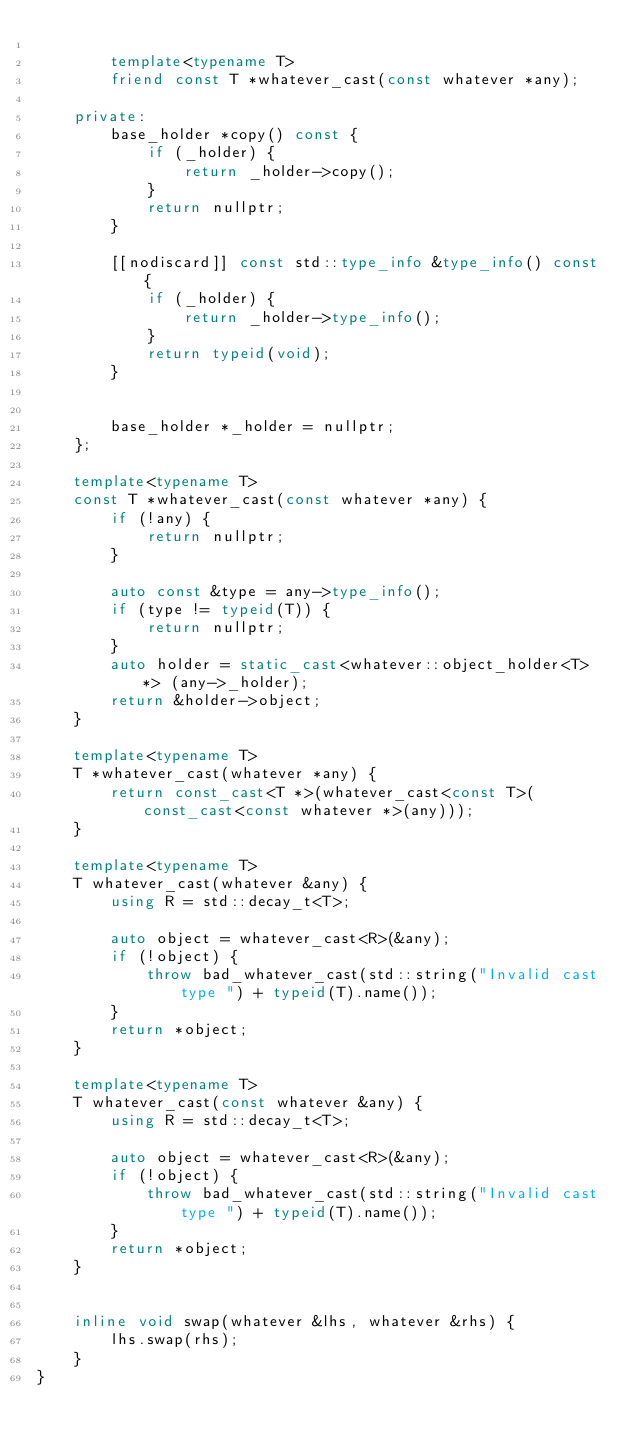Convert code to text. <code><loc_0><loc_0><loc_500><loc_500><_C++_>
        template<typename T>
        friend const T *whatever_cast(const whatever *any);

    private:
        base_holder *copy() const {
            if (_holder) {
                return _holder->copy();
            }
            return nullptr;
        }

        [[nodiscard]] const std::type_info &type_info() const {
            if (_holder) {
                return _holder->type_info();
            }
            return typeid(void);
        }


        base_holder *_holder = nullptr;
    };

    template<typename T>
    const T *whatever_cast(const whatever *any) {
        if (!any) {
            return nullptr;
        }

        auto const &type = any->type_info();
        if (type != typeid(T)) {
            return nullptr;
        }
        auto holder = static_cast<whatever::object_holder<T> *> (any->_holder);
        return &holder->object;
    }

    template<typename T>
    T *whatever_cast(whatever *any) {
        return const_cast<T *>(whatever_cast<const T>(const_cast<const whatever *>(any)));
    }

    template<typename T>
    T whatever_cast(whatever &any) {
        using R = std::decay_t<T>;

        auto object = whatever_cast<R>(&any);
        if (!object) {
            throw bad_whatever_cast(std::string("Invalid cast type ") + typeid(T).name());
        }
        return *object;
    }

    template<typename T>
    T whatever_cast(const whatever &any) {
        using R = std::decay_t<T>;

        auto object = whatever_cast<R>(&any);
        if (!object) {
            throw bad_whatever_cast(std::string("Invalid cast type ") + typeid(T).name());
        }
        return *object;
    }


    inline void swap(whatever &lhs, whatever &rhs) {
        lhs.swap(rhs);
    }
}</code> 